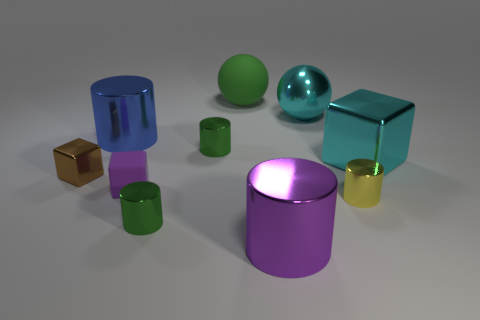Subtract 1 cubes. How many cubes are left? 2 Subtract all small yellow cylinders. How many cylinders are left? 4 Subtract all yellow cylinders. How many cylinders are left? 4 Subtract all blue cylinders. Subtract all green balls. How many cylinders are left? 4 Subtract all balls. How many objects are left? 8 Add 2 metallic cylinders. How many metallic cylinders are left? 7 Add 2 large objects. How many large objects exist? 7 Subtract 1 green spheres. How many objects are left? 9 Subtract all blue cylinders. Subtract all spheres. How many objects are left? 7 